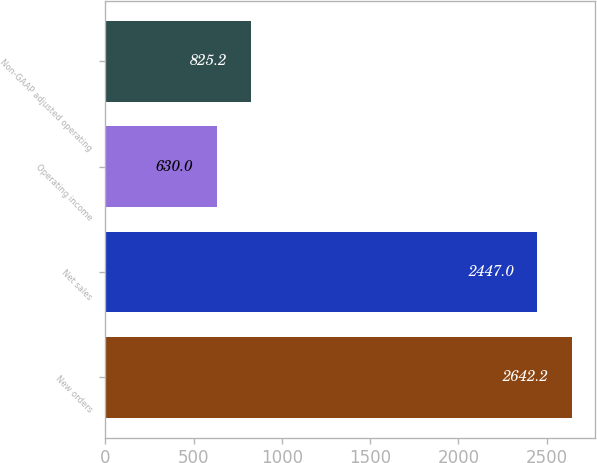<chart> <loc_0><loc_0><loc_500><loc_500><bar_chart><fcel>New orders<fcel>Net sales<fcel>Operating income<fcel>Non-GAAP adjusted operating<nl><fcel>2642.2<fcel>2447<fcel>630<fcel>825.2<nl></chart> 